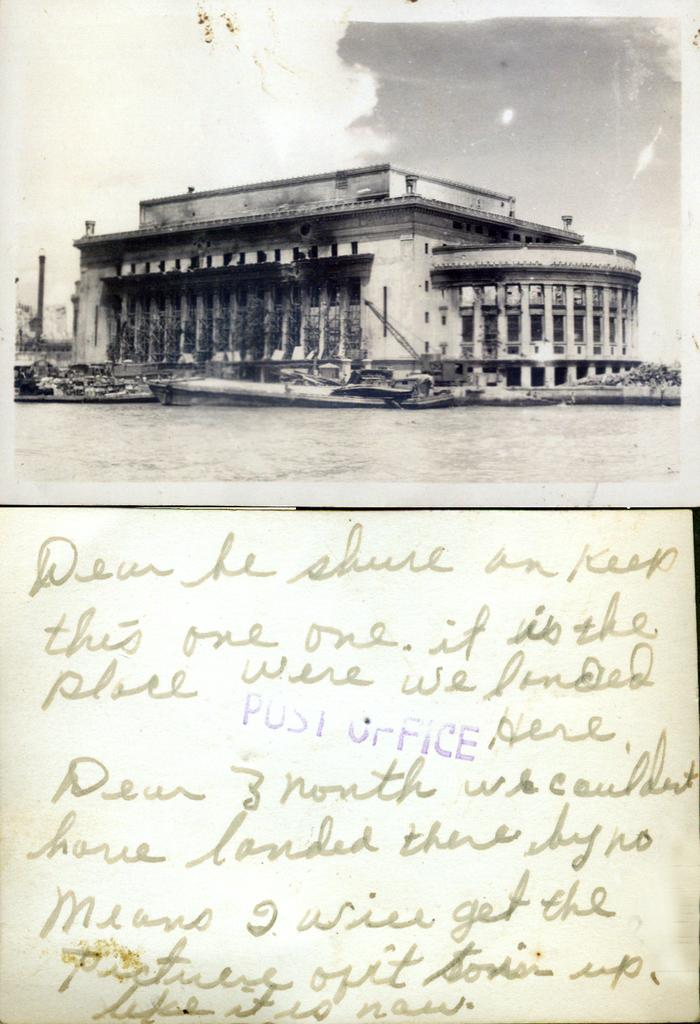<image>
Provide a brief description of the given image. A postcard with writing and a stating to keep this one showing a picture of an old building, 